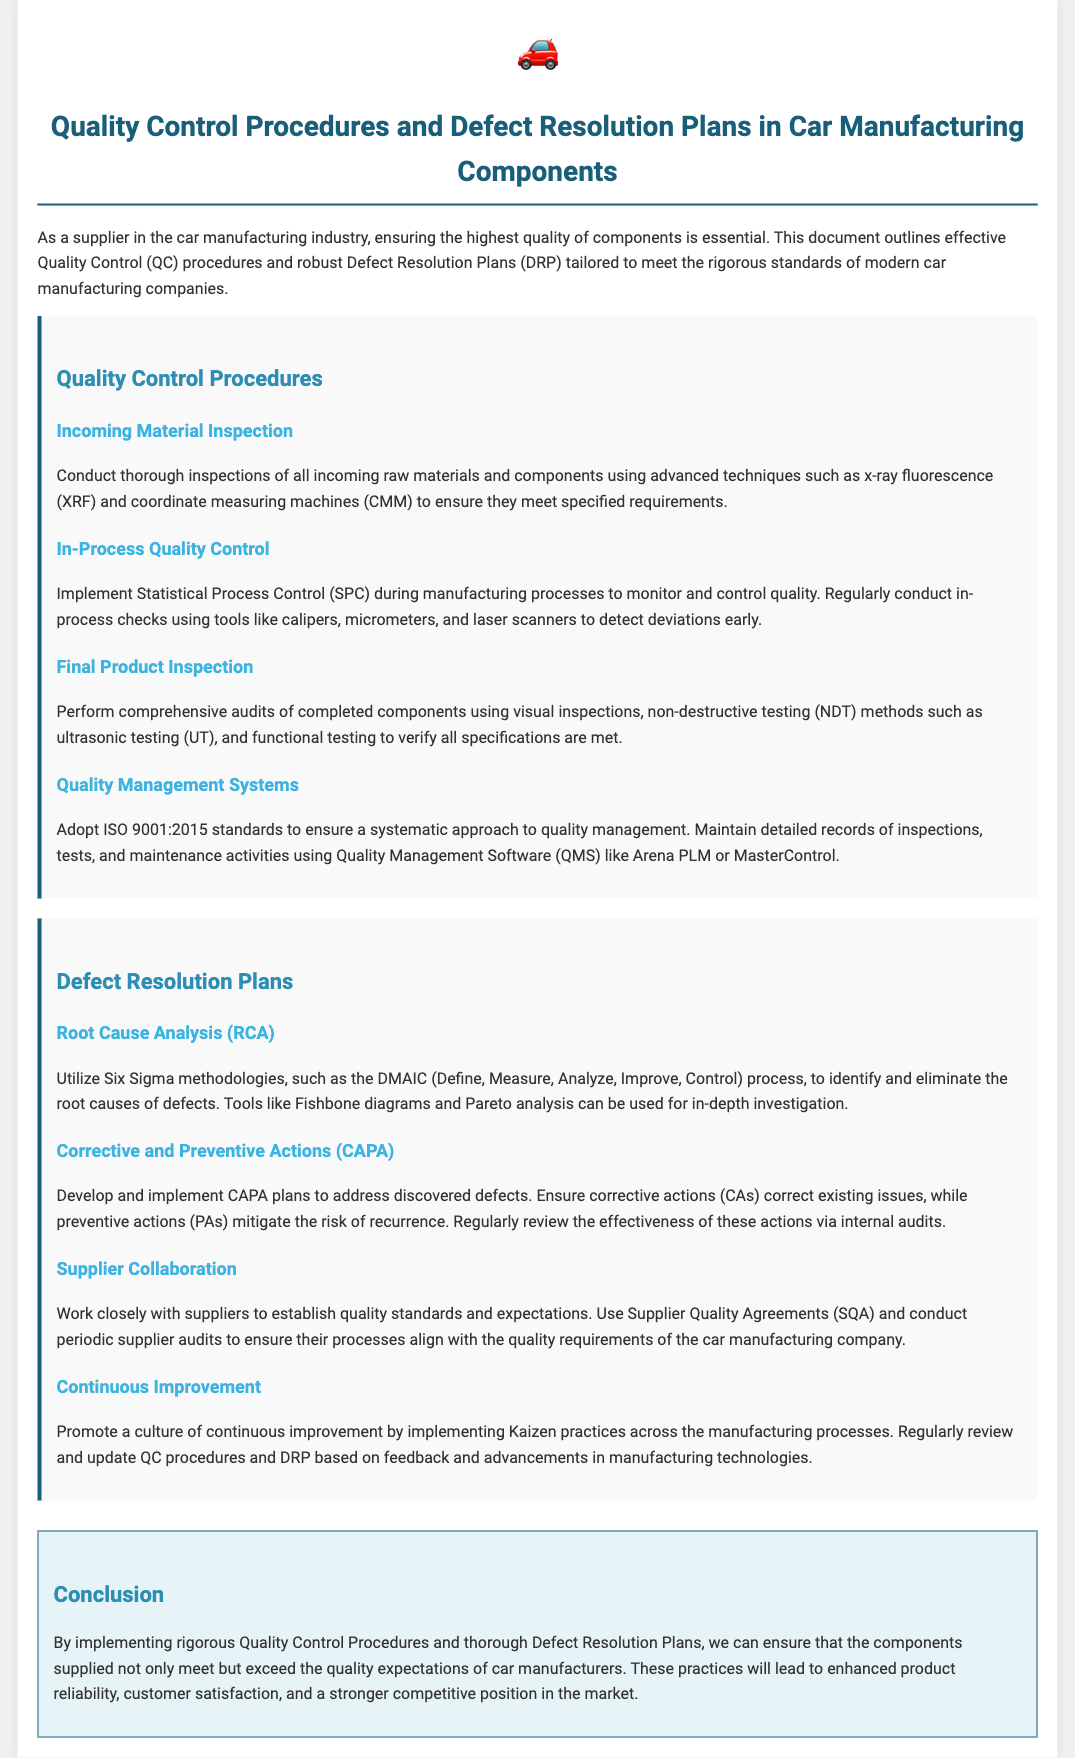what inspection technique is mentioned for incoming materials? The document specifies advanced techniques like x-ray fluorescence (XRF) and coordinate measuring machines (CMM) for incoming materials inspection.
Answer: x-ray fluorescence (XRF) and coordinate measuring machines (CMM) what quality management standards are adopted? The document mentions the adoption of ISO 9001:2015 standards for quality management.
Answer: ISO 9001:2015 which methodology is used for root cause analysis? The document states that Six Sigma methodologies, specifically the DMAIC process, are utilized for root cause analysis.
Answer: DMAIC how are corrective actions verified? The document explains that the effectiveness of corrective actions is regularly reviewed via internal audits.
Answer: internal audits what practice promotes continuous improvement? The document indicates that Kaizen practices are implemented to promote a culture of continuous improvement.
Answer: Kaizen how often should in-process checks be conducted? The document advises regularly conducting in-process checks during manufacturing processes.
Answer: regularly which testing method is used for final product inspection? The document highlights using non-destructive testing (NDT) methods such as ultrasonic testing (UT) for final product inspection.
Answer: ultrasonic testing (UT) 